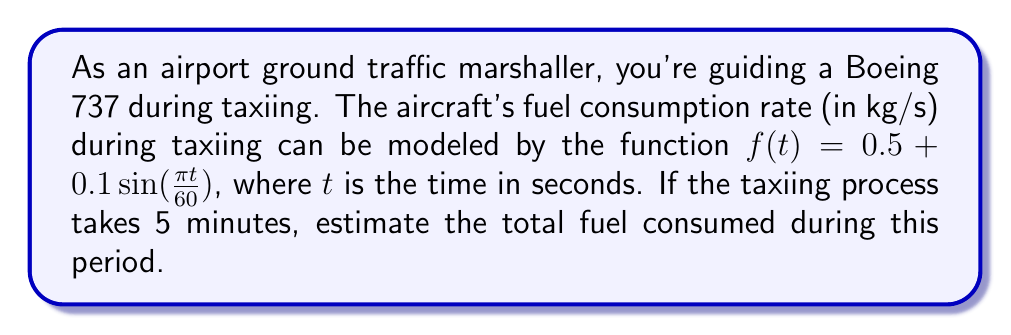Could you help me with this problem? To solve this problem, we need to integrate the fuel consumption rate function over the given time period. Let's break it down step-by-step:

1) The fuel consumption rate is given by:
   $f(t) = 0.5 + 0.1\sin(\frac{\pi t}{60})$ kg/s

2) We need to integrate this function from $t = 0$ to $t = 300$ seconds (5 minutes = 300 seconds):

   $$\int_0^{300} (0.5 + 0.1\sin(\frac{\pi t}{60})) dt$$

3) Let's break this integral into two parts:
   
   $$\int_0^{300} 0.5 dt + \int_0^{300} 0.1\sin(\frac{\pi t}{60}) dt$$

4) For the first part:
   $$0.5t \bigg|_0^{300} = 0.5(300) - 0.5(0) = 150$$

5) For the second part, we use the substitution method:
   Let $u = \frac{\pi t}{60}$, then $du = \frac{\pi}{60} dt$, or $dt = \frac{60}{\pi} du$
   
   When $t = 0$, $u = 0$
   When $t = 300$, $u = 5\pi$

   So, the second integral becomes:
   $$0.1 \cdot \frac{60}{\pi} \int_0^{5\pi} \sin(u) du$$

6) Solving this:
   $$0.1 \cdot \frac{60}{\pi} [-\cos(u)]_0^{5\pi} = \frac{6}{\pi} [-\cos(5\pi) + \cos(0)] = \frac{6}{\pi} [1 + 1] = \frac{12}{\pi}$$

7) Adding the results from steps 4 and 6:
   
   Total fuel consumed = $150 + \frac{12}{\pi}$ kg
Answer: $150 + \frac{12}{\pi}$ kg 